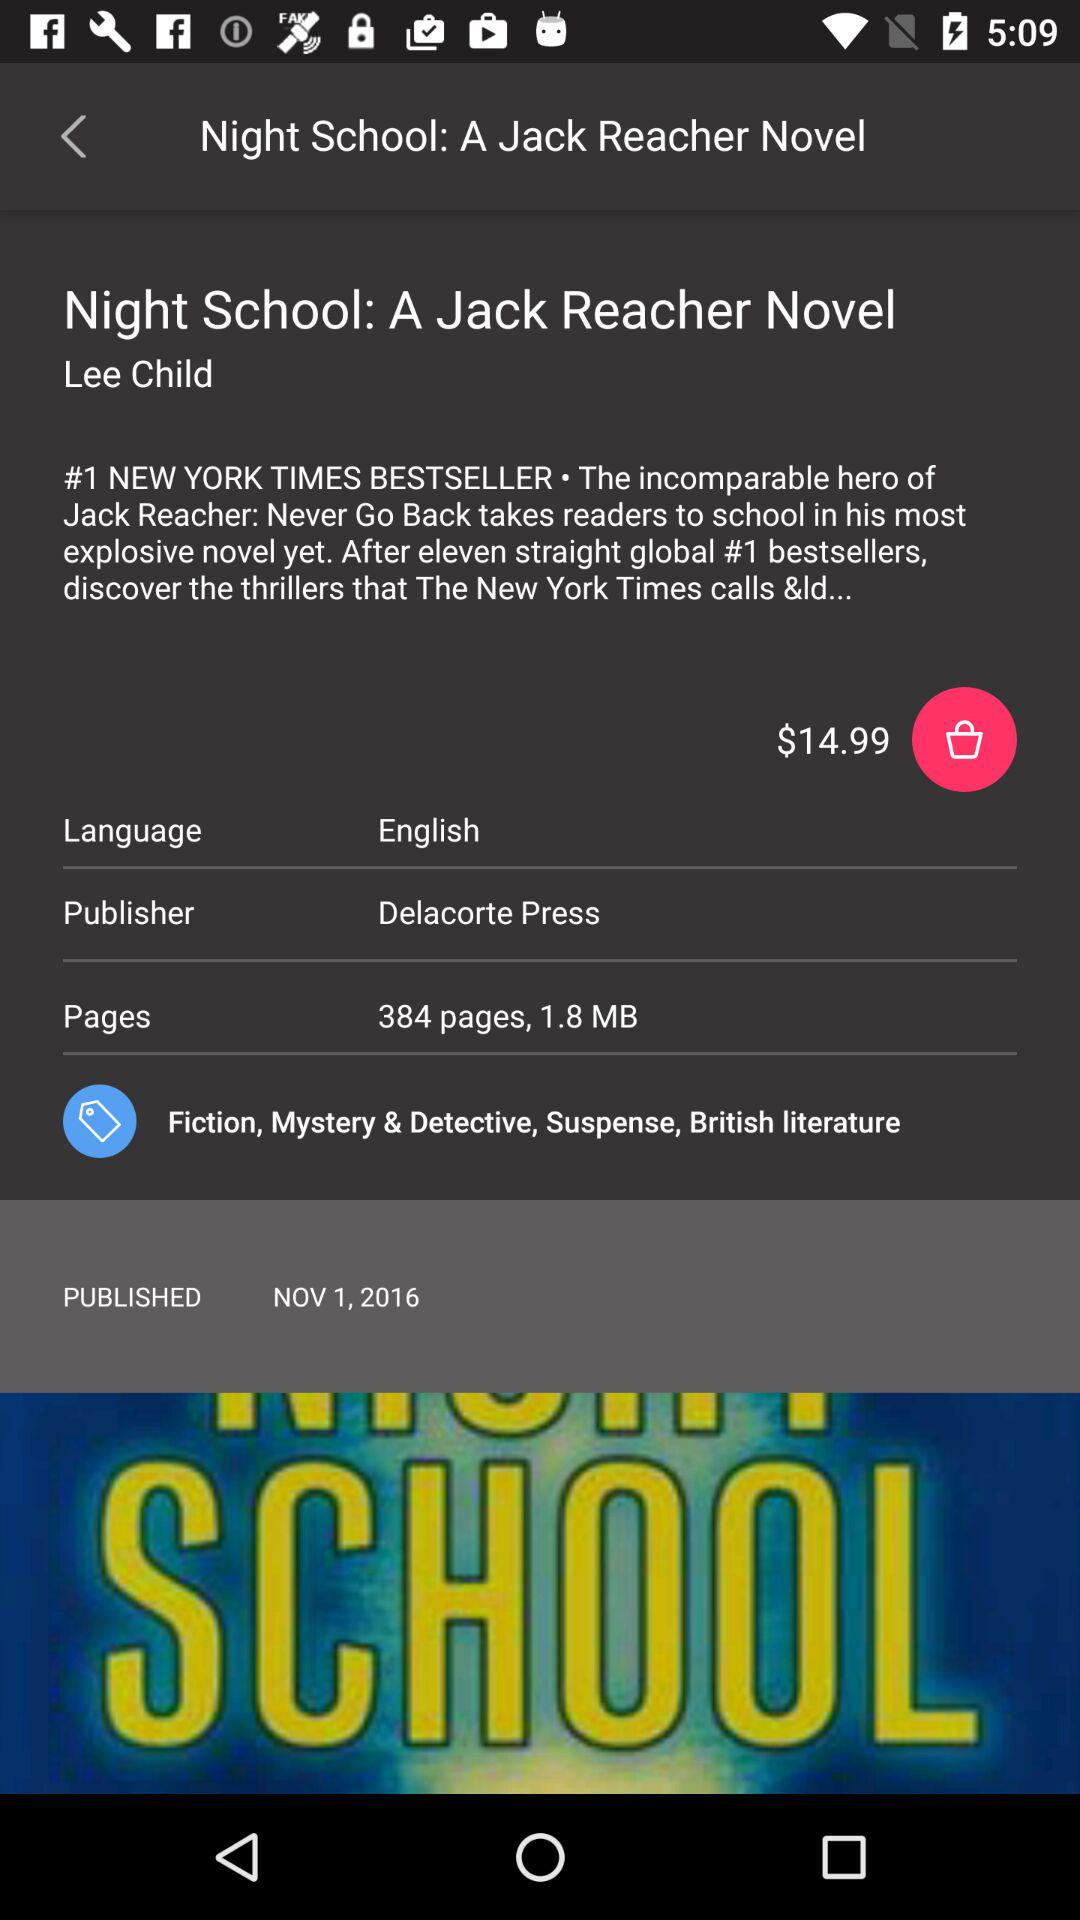What is the mentioned language? The mentioned language is English. 